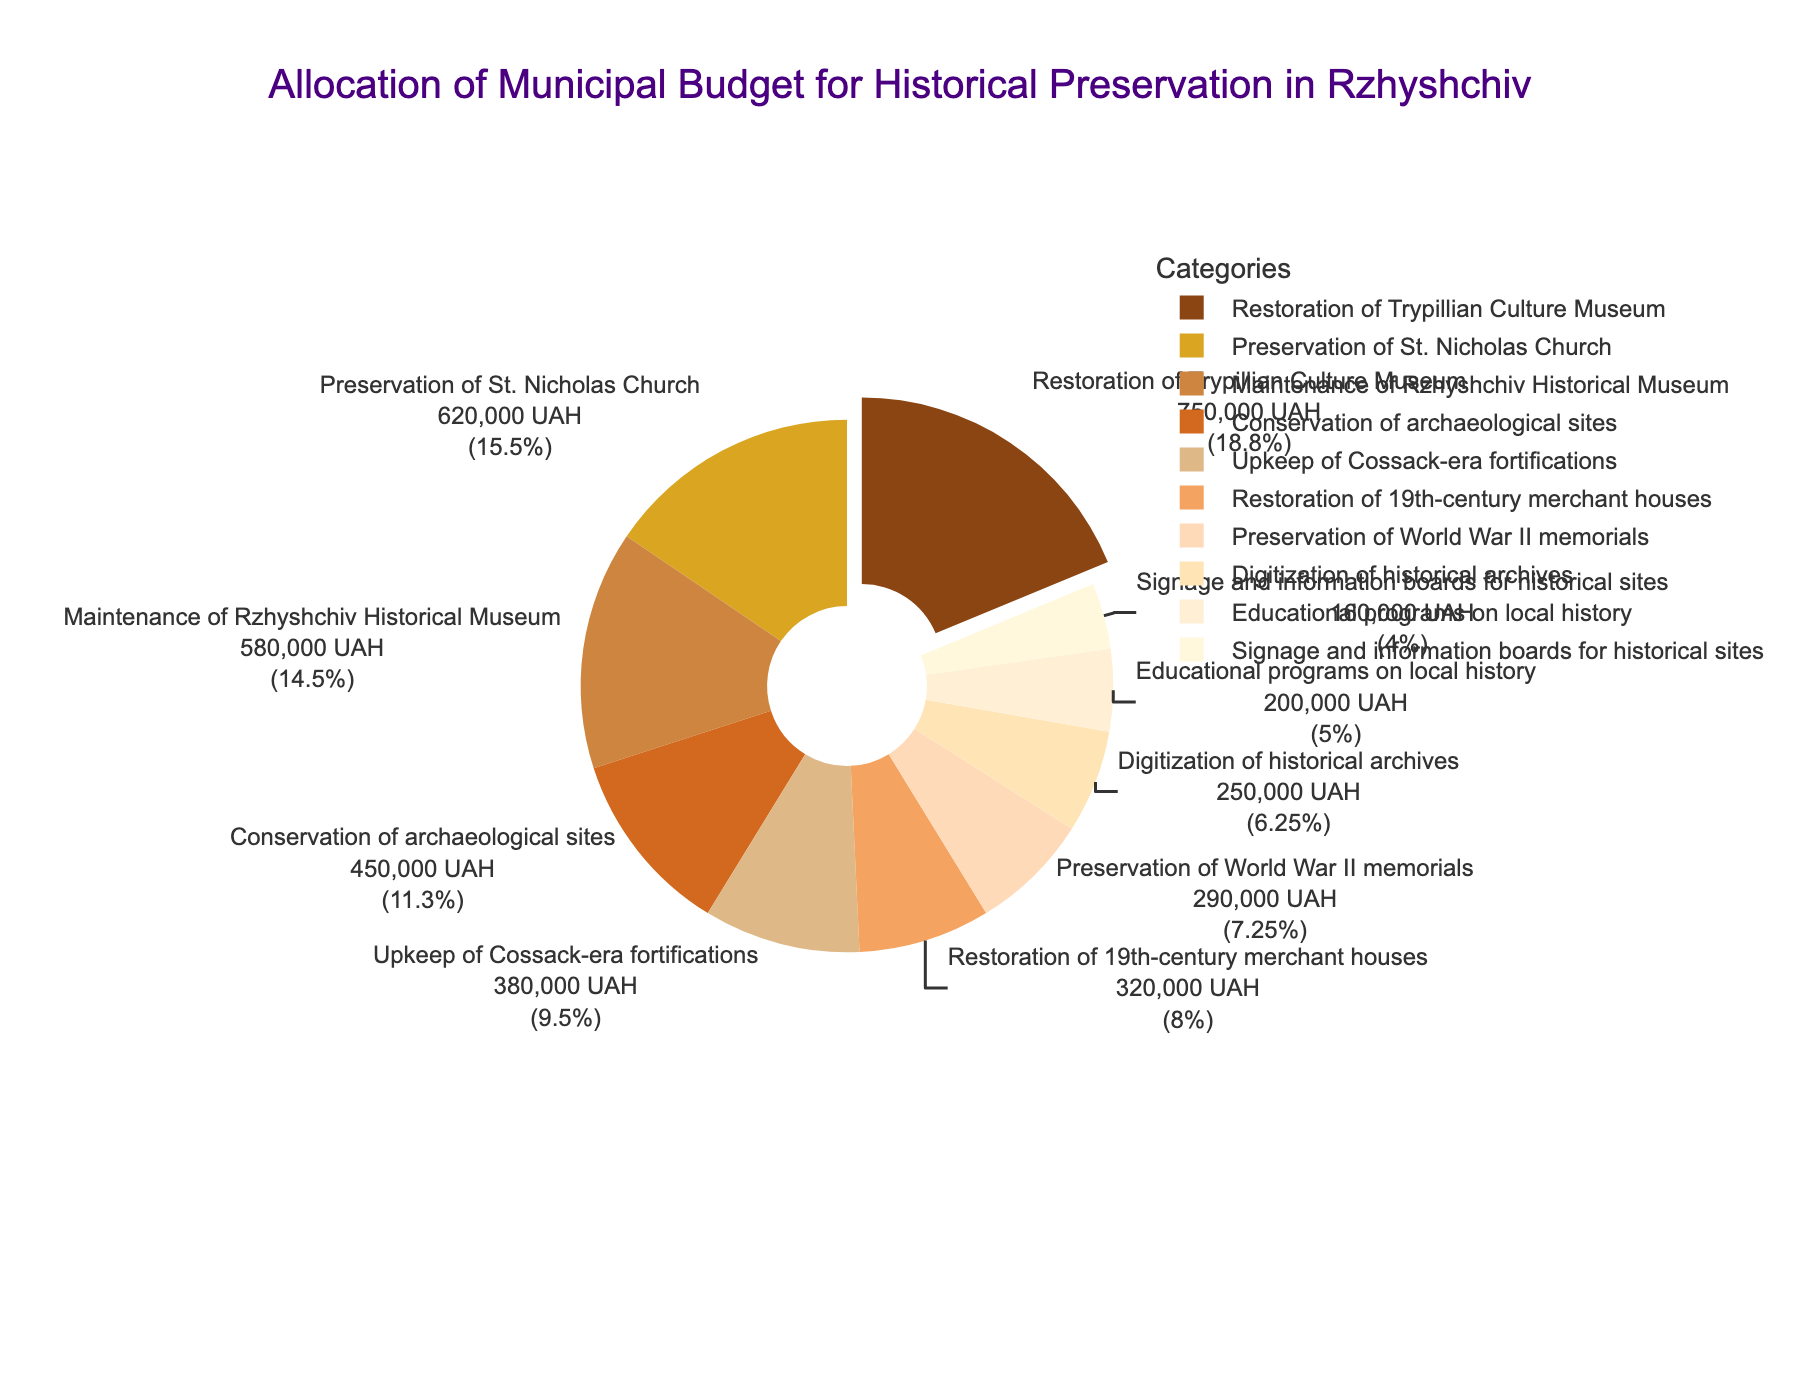What's the largest allocation in the budget? The largest allocation is represented by the slice that is slightly pulled out from the pie chart. This slice is for the Restoration of Trypillian Culture Museum with a budget allocation of 750,000 UAH.
Answer: Restoration of Trypillian Culture Museum How much more is allocated to the Preservation of St. Nicholas Church compared to the Upkeep of Cossack-era fortifications? To find this, we subtract the budget for the Upkeep of Cossack-era fortifications (380,000 UAH) from the budget for the Preservation of St. Nicholas Church (620,000 UAH). The difference is 620,000 - 380,000 = 240,000 UAH.
Answer: 240,000 UAH Which category has the smallest budget allocation? The smallest allocation is for Signage and information boards for historical sites with a budget of 160,000 UAH.
Answer: Signage and information boards for historical sites What percentage of the budget is allocated to the Conservation of archeological sites? The pie chart shows percentage allocations for each category. The slice for Conservation of archaeological sites shows its allocated percentage.
Answer: 11% What is the total budget allocated for educational programs on local history and digitization of historical archives combined? Add the budget allocations for both categories: Educational programs on local history (200,000 UAH) and Digitization of historical archives (250,000 UAH). The total is 200,000 + 250,000 = 450,000 UAH.
Answer: 450,000 UAH Which category has a higher budget allocation, Restoration of 19th-century merchant houses or Preservation of World War II memorials? By comparing the two slices, the Restoration of 19th-century merchant houses has a higher budget allocation (320,000 UAH) compared to Preservation of World War II memorials (290,000 UAH).
Answer: Restoration of 19th-century merchant houses If the total budget is 4,000,000 UAH, what percentage of the total budget is allocated to Maintenance of Rzhyshchiv Historical Museum? To find the percentage, we divide the budget for Maintenance of Rzhyshchiv Historical Museum (580,000 UAH) by the total budget (4,000,000 UAH) and multiply by 100. The calculation is (580,000 / 4,000,000) * 100 = 14.5%.
Answer: 14.5% Which segment of the pie chart is color-coded in gold? The segment colored in gold represents the Preservation of St. Nicholas Church.
Answer: Preservation of St. Nicholas Church What is the combined budget for Restoration of Trypillian Culture Museum and Maintenance of Rzhyshchiv Historical Museum? Add the budget allocations for both categories: Restoration of Trypillian Culture Museum (750,000 UAH) and Maintenance of Rzhyshchiv Historical Museum (580,000 UAH). The total is 750,000 + 580,000 = 1,330,000 UAH.
Answer: 1,330,000 UAH 